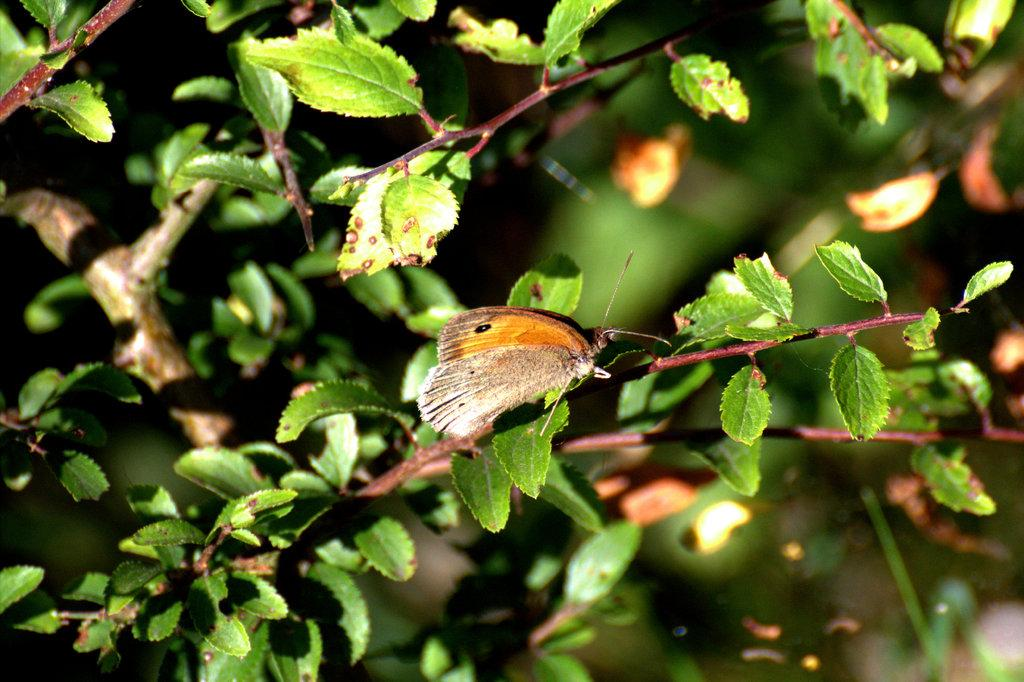What type of plant parts can be seen in the image? There are stems and leaves in the image. What other living organism is present in the image? There is a butterfly in the image. How many legs can be seen on the family in the image? There is no family present in the image, and therefore no legs can be counted. What is the position of the moon in the image? There is no moon present in the image. 